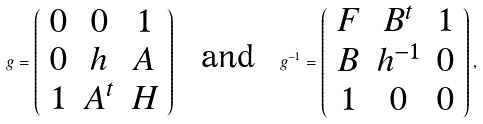<formula> <loc_0><loc_0><loc_500><loc_500>g = \left ( \begin{array} { c c c } 0 & 0 & 1 \\ 0 & h & A \\ 1 & A ^ { t } & H \end{array} \right ) \ \text { and } \ g ^ { - 1 } = \left ( \begin{array} { c c c } F & B ^ { t } & 1 \\ B & h ^ { - 1 } & 0 \\ 1 & 0 & 0 \end{array} \right ) ,</formula> 